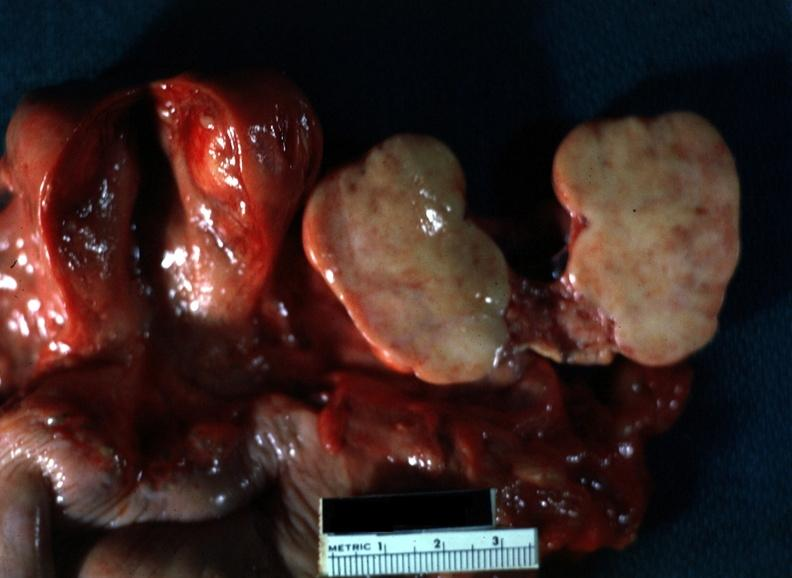s thecoma present?
Answer the question using a single word or phrase. Yes 